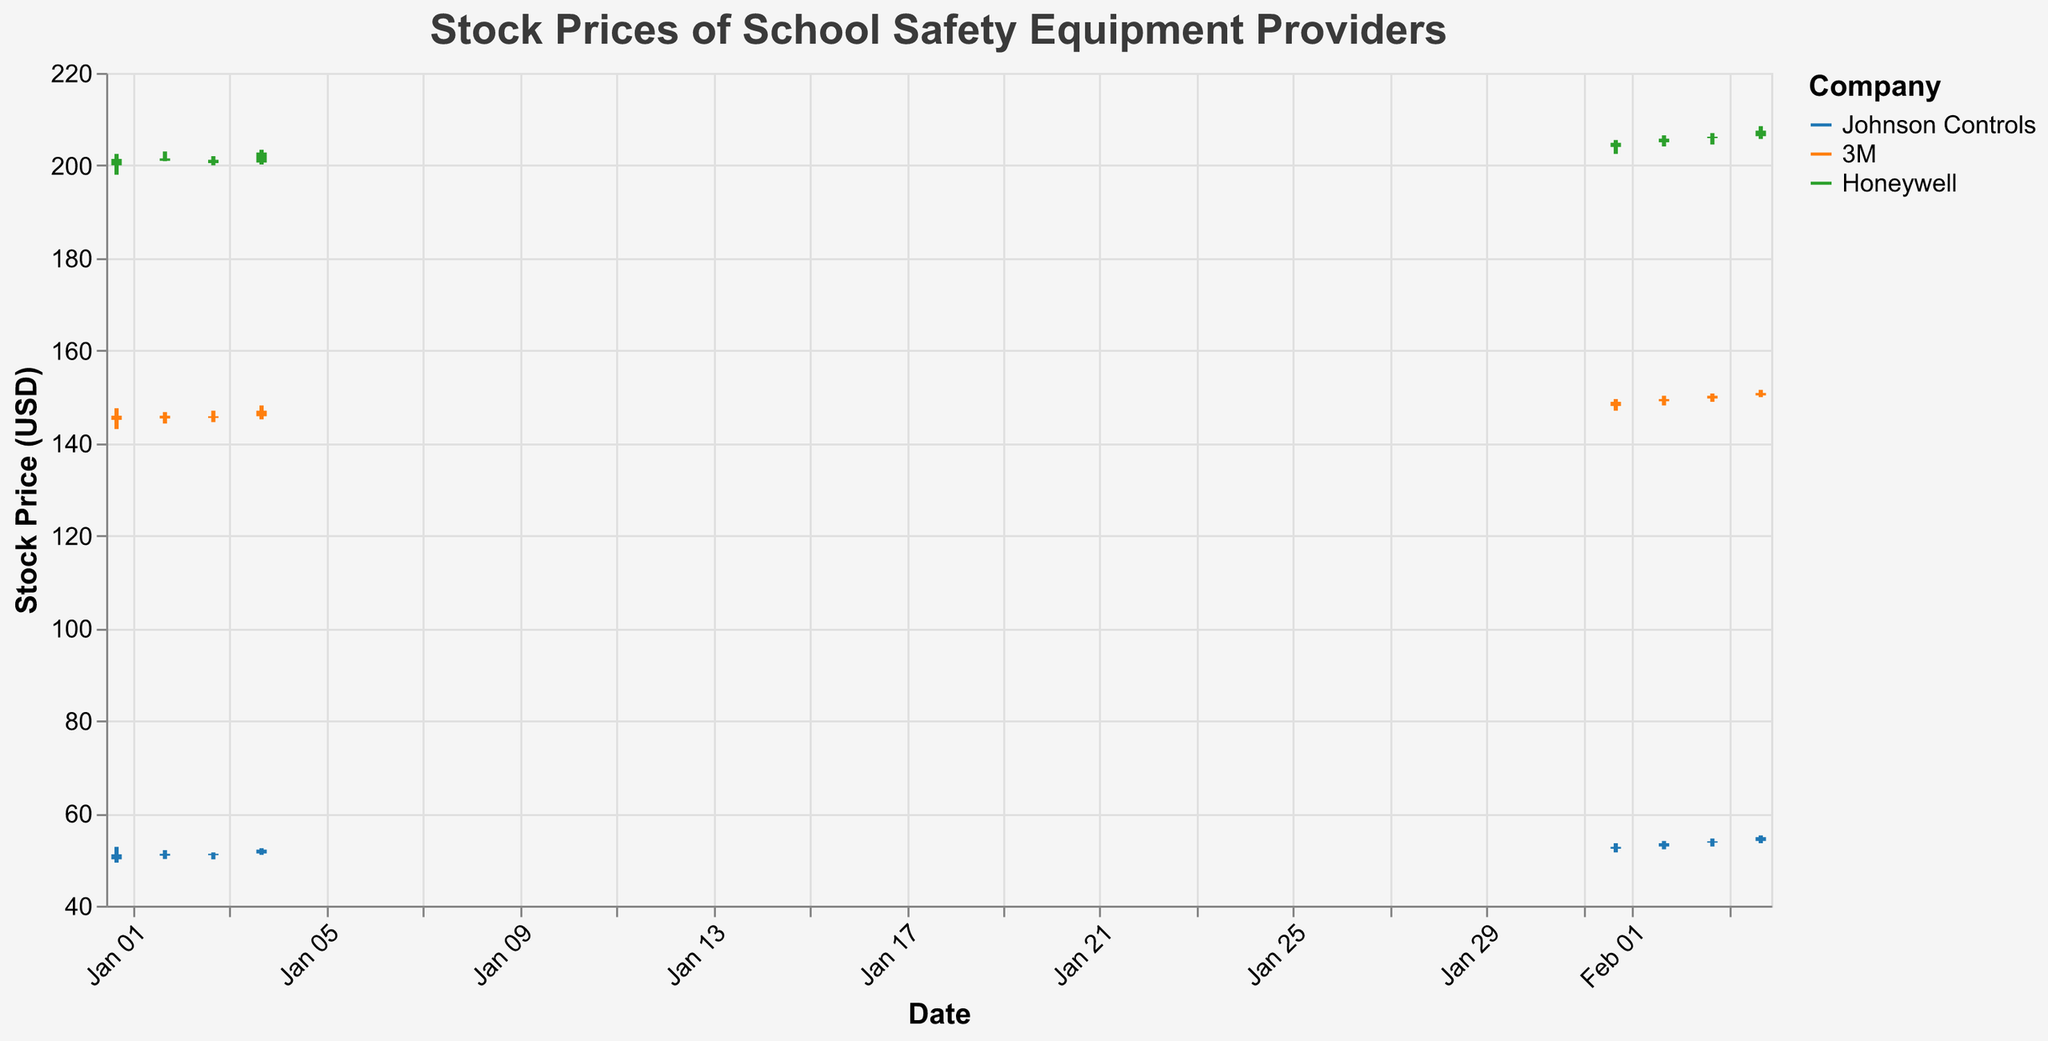What are the companies analyzed in the figure? The companies analyzed in the figure are listed in the legend, which provides names and corresponding colors. The companies are Johnson Controls, 3M, and Honeywell.
Answer: Johnson Controls, 3M, Honeywell Which company had the highest closing price in January? To determine the highest closing price in January, look at the closing prices of Johnson Controls, 3M, and Honeywell in January. Honeywell has the highest closing price: it closed on January 1 at $201.4.
Answer: Honeywell How did Johnson Controls' stock price trend from January to February? By examining the candlestick bars for Johnson Controls in January and February, we can see that the stock price had an upward trend. It started around $50 on January 1 and increased to approximately $54.8 by February 4.
Answer: Upward Which company had the highest trading volume in February and on which date? By observing the volumes in February, 3M stood out with the highest trading volume of 2,400,000 on February 4.
Answer: 3M, February 4 What is the difference between the highest and lowest closing prices for 3M in January? To find the difference, look at the highest and lowest closing prices for 3M in January. The highest is $147.0 (January 4) and the lowest is $145.3 (January 2). So, the difference is $147.0 - $145.3 = $1.7.
Answer: $1.7 Compare the highest stock price of Honeywell between January and February. Which month had a higher peak? Honeywell’s highest stock price in January was $203.4, and in February, it peaked at $208.5. Therefore, February had a higher peak.
Answer: February What is the average closing price of Johnson Controls in February? The average closing price is found by summing the closing prices for Johnson Controls in February and dividing by the number of data points. They are $52.7, $53.5, $53.9, and $54.8. The sum is $52.7 + $53.5 + $53.9 + $54.8 = $214.9. Dividing by 4 gives $214.9 / 4 = $53.725.
Answer: $53.725 How does the price range (difference between high and low) compare between 3M and Honeywell on February 1, 2023? On February 1, 3M’s price range is $149.5 - $147.0 = $2.5, while Honeywell’s range is $205.5 - $202.5 = $3.0. Honeywell has a larger price range on this date.
Answer: Honeywell Which company's stock price increased the most from January 1 to January 4? By comparing the closing prices from January 1 to 4 for all companies, we see the increase for Johnson Controls is $52.1 - $51.1 = $1.0, for 3M is $147.0 - $145.9 = $1.1, and for Honeywell is $202.8 - $201.4 = $1.4. Honeywell had the highest increase.
Answer: Honeywell 